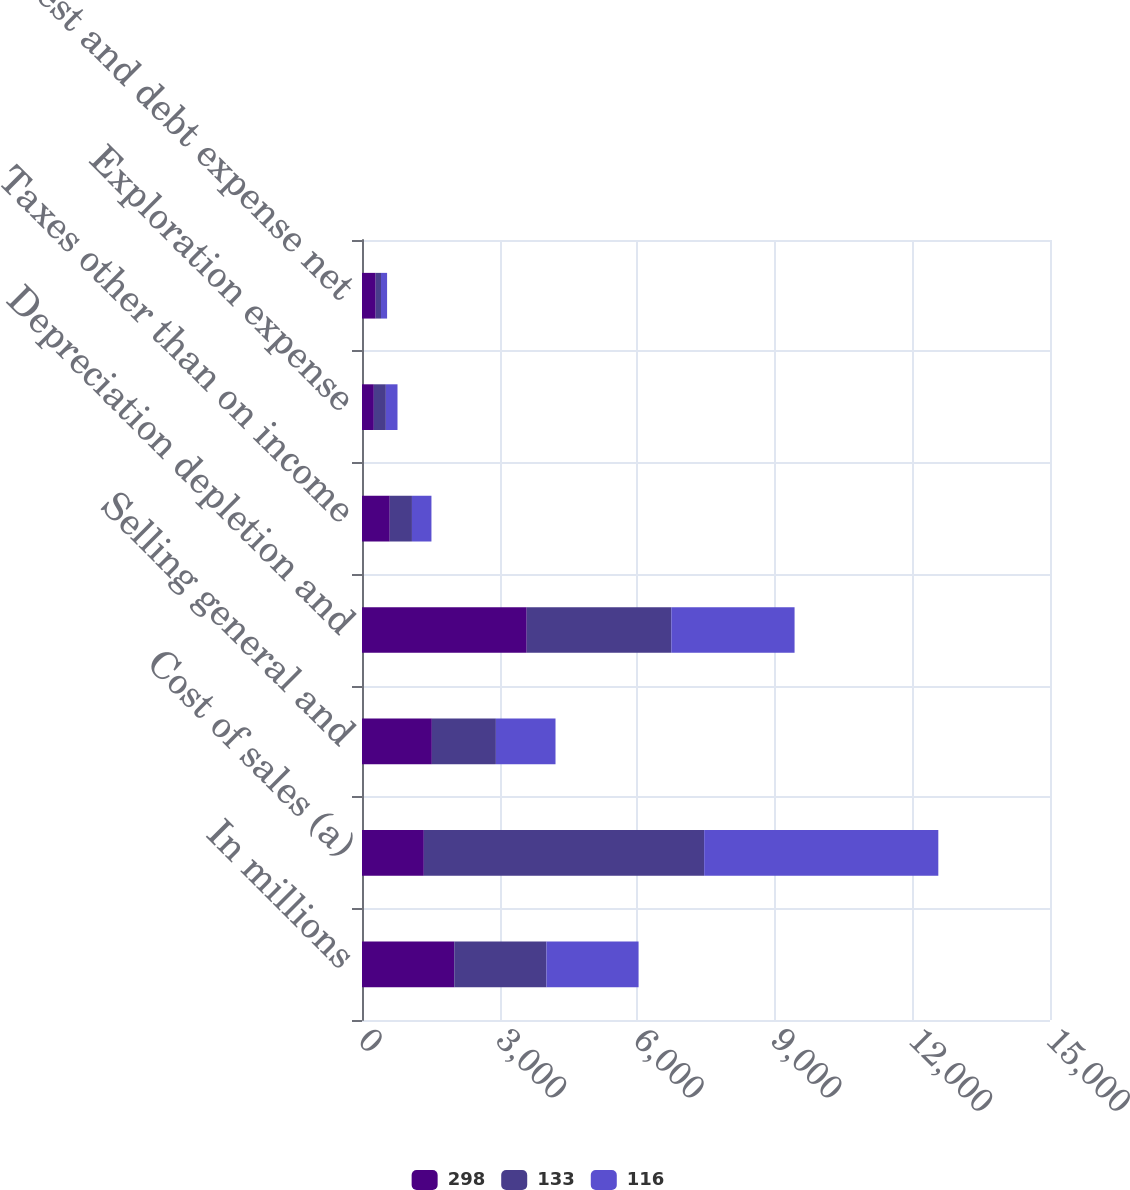Convert chart. <chart><loc_0><loc_0><loc_500><loc_500><stacked_bar_chart><ecel><fcel>In millions<fcel>Cost of sales (a)<fcel>Selling general and<fcel>Depreciation depletion and<fcel>Taxes other than on income<fcel>Exploration expense<fcel>Interest and debt expense net<nl><fcel>298<fcel>2011<fcel>1348<fcel>1523<fcel>3591<fcel>605<fcel>258<fcel>298<nl><fcel>133<fcel>2010<fcel>6112<fcel>1396<fcel>3153<fcel>484<fcel>262<fcel>116<nl><fcel>116<fcel>2009<fcel>5105<fcel>1300<fcel>2687<fcel>425<fcel>254<fcel>133<nl></chart> 